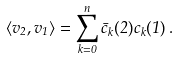Convert formula to latex. <formula><loc_0><loc_0><loc_500><loc_500>\langle v _ { 2 } , v _ { 1 } \rangle = \sum _ { k = 0 } ^ { n } \bar { c } _ { k } ( 2 ) c _ { k } ( 1 ) \, .</formula> 